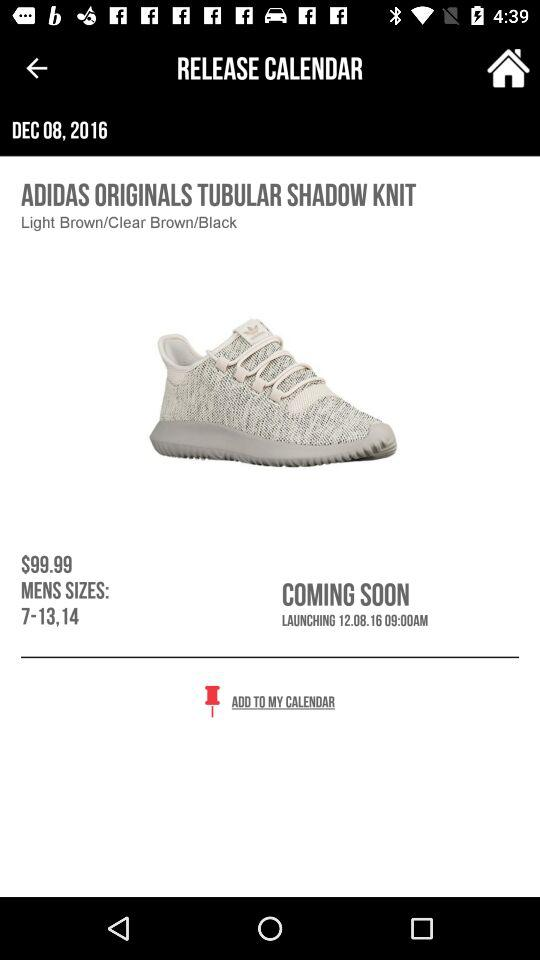What is the given date in the release calendar? The given date is December 8, 2016. 